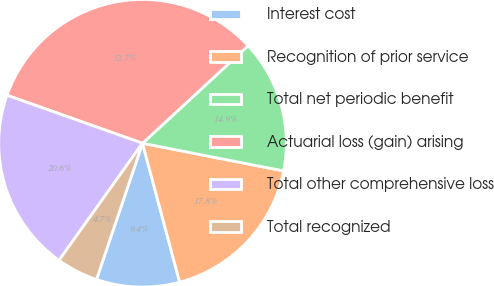Convert chart to OTSL. <chart><loc_0><loc_0><loc_500><loc_500><pie_chart><fcel>Interest cost<fcel>Recognition of prior service<fcel>Total net periodic benefit<fcel>Actuarial loss (gain) arising<fcel>Total other comprehensive loss<fcel>Total recognized<nl><fcel>9.35%<fcel>17.76%<fcel>14.95%<fcel>32.71%<fcel>20.56%<fcel>4.67%<nl></chart> 